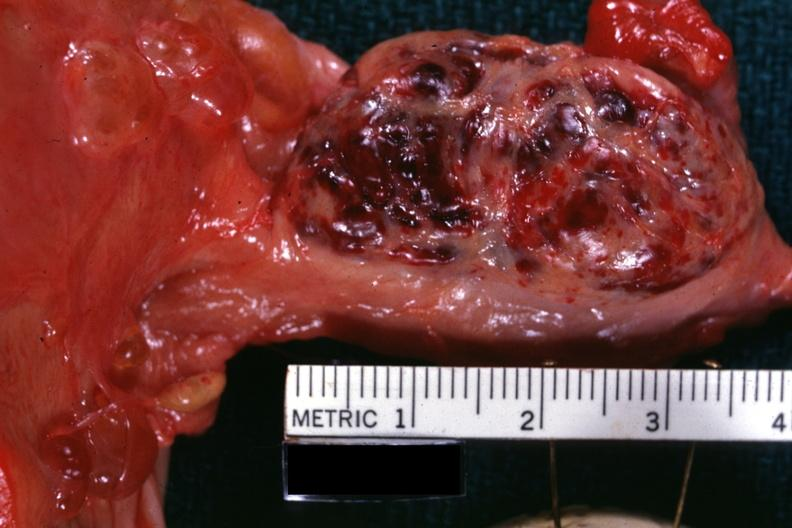what is present?
Answer the question using a single word or phrase. Female reproductive 